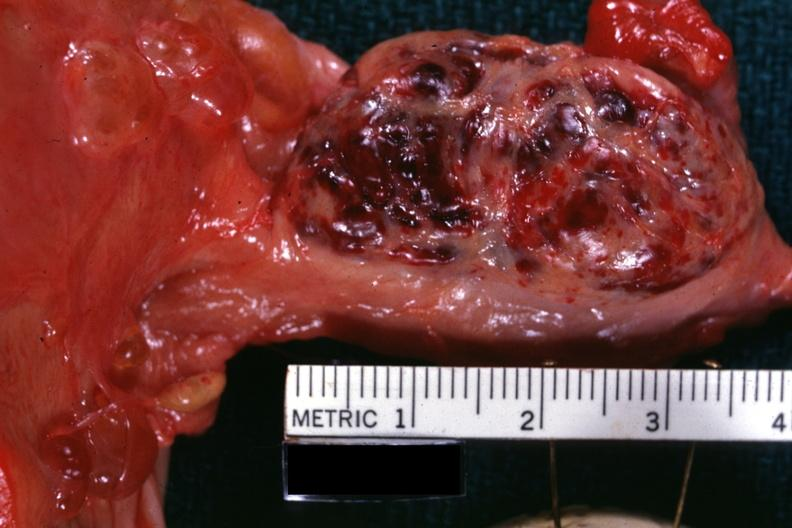what is present?
Answer the question using a single word or phrase. Female reproductive 